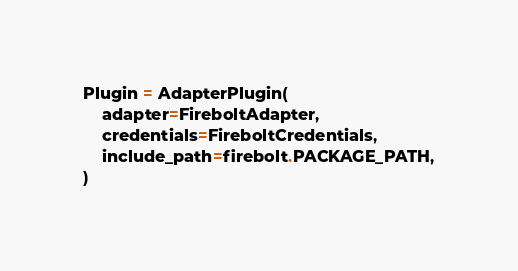<code> <loc_0><loc_0><loc_500><loc_500><_Python_>Plugin = AdapterPlugin(
    adapter=FireboltAdapter,
    credentials=FireboltCredentials,
    include_path=firebolt.PACKAGE_PATH,
)
</code> 